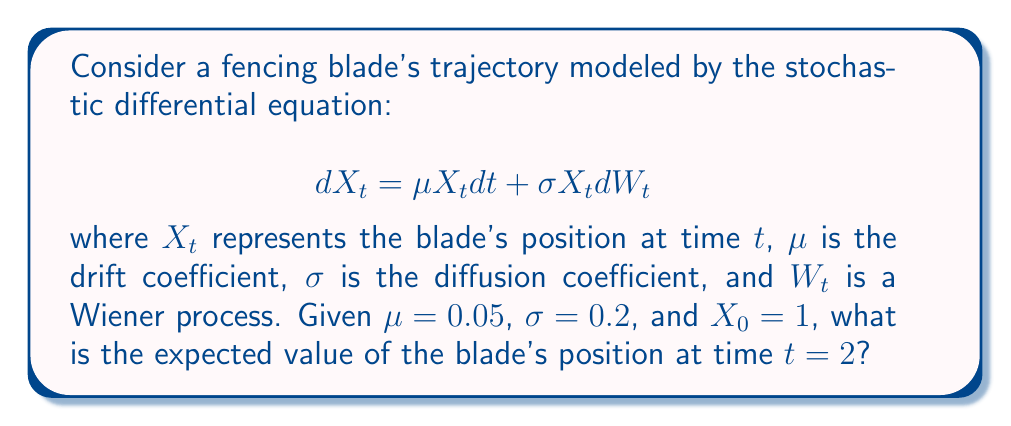Solve this math problem. To solve this problem, we'll follow these steps:

1) The given stochastic differential equation (SDE) is a geometric Brownian motion. For this type of SDE, we can use Itô's formula to derive the solution:

   $$X_t = X_0 \exp\left(\left(\mu - \frac{\sigma^2}{2}\right)t + \sigma W_t\right)$$

2) To find the expected value, we need to use the property that for any constant $a$, $E[e^{aW_t}] = e^{\frac{1}{2}a^2t}$. This is because $W_t$ follows a normal distribution with mean 0 and variance $t$.

3) Taking the expectation of both sides:

   $$E[X_t] = X_0 \exp\left(\mu t\right)$$

4) Now, let's substitute the given values:
   $X_0 = 1$
   $\mu = 0.05$
   $t = 2$

5) Calculating:

   $$E[X_2] = 1 \cdot \exp(0.05 \cdot 2) = e^{0.1}$$

6) Using a calculator or approximating $e^{0.1}$:

   $$E[X_2] \approx 1.1052$$

Therefore, the expected value of the blade's position at time $t = 2$ is approximately 1.1052.
Answer: $1.1052$ 